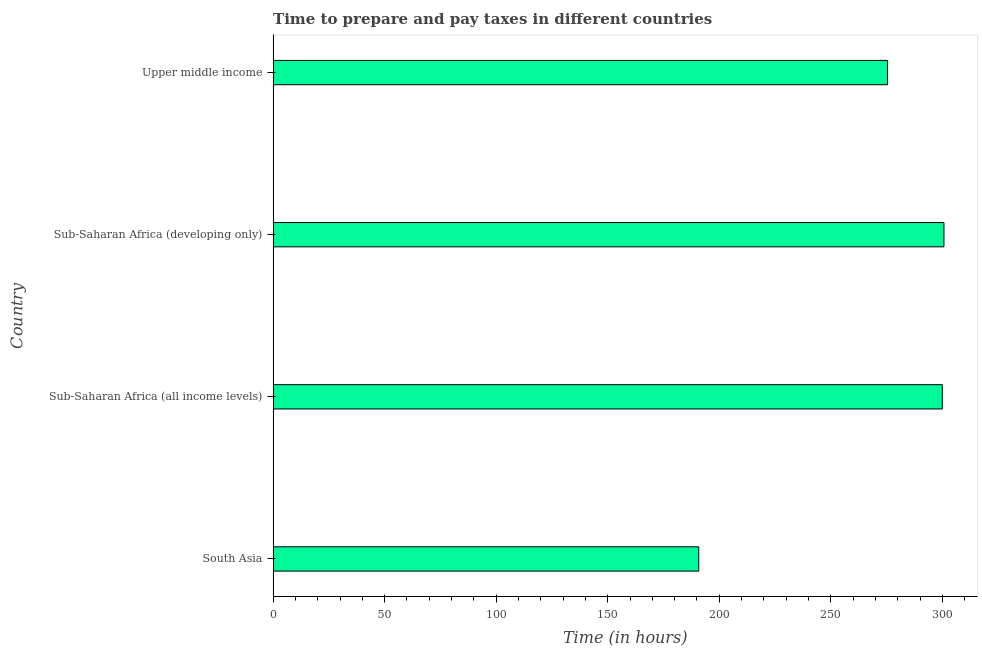What is the title of the graph?
Offer a terse response. Time to prepare and pay taxes in different countries. What is the label or title of the X-axis?
Offer a very short reply. Time (in hours). What is the time to prepare and pay taxes in South Asia?
Your answer should be compact. 190.8. Across all countries, what is the maximum time to prepare and pay taxes?
Your answer should be compact. 300.72. Across all countries, what is the minimum time to prepare and pay taxes?
Your answer should be compact. 190.8. In which country was the time to prepare and pay taxes maximum?
Your answer should be compact. Sub-Saharan Africa (developing only). In which country was the time to prepare and pay taxes minimum?
Your answer should be compact. South Asia. What is the sum of the time to prepare and pay taxes?
Your response must be concise. 1066.94. What is the difference between the time to prepare and pay taxes in Sub-Saharan Africa (all income levels) and Sub-Saharan Africa (developing only)?
Ensure brevity in your answer.  -0.74. What is the average time to prepare and pay taxes per country?
Your response must be concise. 266.74. What is the median time to prepare and pay taxes?
Keep it short and to the point. 287.71. Is the difference between the time to prepare and pay taxes in South Asia and Sub-Saharan Africa (all income levels) greater than the difference between any two countries?
Offer a terse response. No. What is the difference between the highest and the second highest time to prepare and pay taxes?
Offer a very short reply. 0.74. What is the difference between the highest and the lowest time to prepare and pay taxes?
Give a very brief answer. 109.92. In how many countries, is the time to prepare and pay taxes greater than the average time to prepare and pay taxes taken over all countries?
Provide a short and direct response. 3. How many bars are there?
Offer a very short reply. 4. What is the difference between two consecutive major ticks on the X-axis?
Provide a succinct answer. 50. What is the Time (in hours) in South Asia?
Your answer should be very brief. 190.8. What is the Time (in hours) of Sub-Saharan Africa (all income levels)?
Make the answer very short. 299.98. What is the Time (in hours) of Sub-Saharan Africa (developing only)?
Ensure brevity in your answer.  300.72. What is the Time (in hours) of Upper middle income?
Offer a very short reply. 275.44. What is the difference between the Time (in hours) in South Asia and Sub-Saharan Africa (all income levels)?
Provide a short and direct response. -109.18. What is the difference between the Time (in hours) in South Asia and Sub-Saharan Africa (developing only)?
Provide a succinct answer. -109.92. What is the difference between the Time (in hours) in South Asia and Upper middle income?
Offer a terse response. -84.64. What is the difference between the Time (in hours) in Sub-Saharan Africa (all income levels) and Sub-Saharan Africa (developing only)?
Offer a terse response. -0.74. What is the difference between the Time (in hours) in Sub-Saharan Africa (all income levels) and Upper middle income?
Your answer should be compact. 24.54. What is the difference between the Time (in hours) in Sub-Saharan Africa (developing only) and Upper middle income?
Make the answer very short. 25.28. What is the ratio of the Time (in hours) in South Asia to that in Sub-Saharan Africa (all income levels)?
Your answer should be very brief. 0.64. What is the ratio of the Time (in hours) in South Asia to that in Sub-Saharan Africa (developing only)?
Provide a succinct answer. 0.63. What is the ratio of the Time (in hours) in South Asia to that in Upper middle income?
Provide a succinct answer. 0.69. What is the ratio of the Time (in hours) in Sub-Saharan Africa (all income levels) to that in Upper middle income?
Provide a succinct answer. 1.09. What is the ratio of the Time (in hours) in Sub-Saharan Africa (developing only) to that in Upper middle income?
Your answer should be compact. 1.09. 